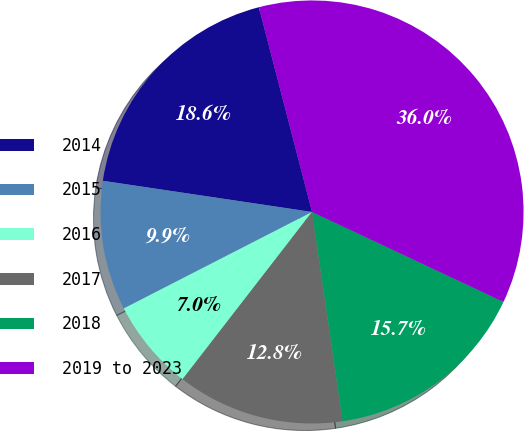Convert chart. <chart><loc_0><loc_0><loc_500><loc_500><pie_chart><fcel>2014<fcel>2015<fcel>2016<fcel>2017<fcel>2018<fcel>2019 to 2023<nl><fcel>18.6%<fcel>9.89%<fcel>6.98%<fcel>12.79%<fcel>15.7%<fcel>36.03%<nl></chart> 